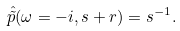<formula> <loc_0><loc_0><loc_500><loc_500>\hat { \tilde { p } } ( \omega = - i , s + r ) = s ^ { - 1 } .</formula> 